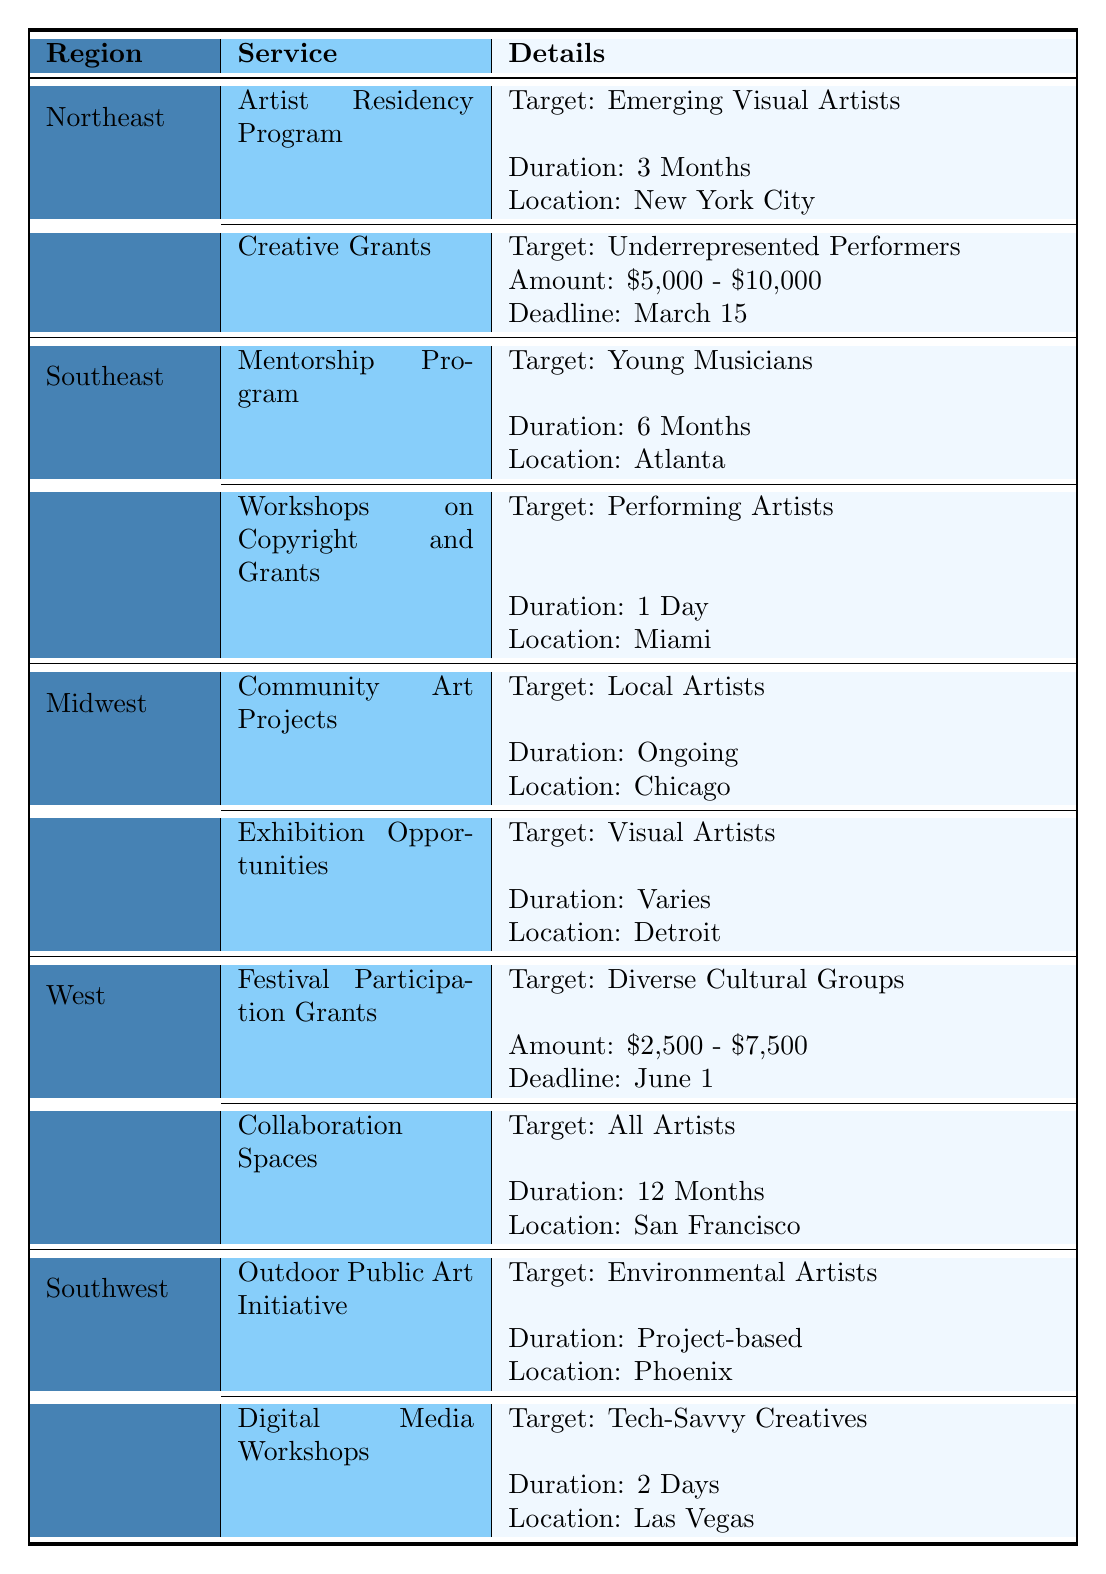What services are offered for emerging visual artists in the Northeast? The table shows that in the Northeast, the Artist Residency Program targets emerging visual artists.
Answer: Artist Residency Program What is the application deadline for the Creative Grants in the Northeast region? Looking at the Northeast section, the application deadline for Creative Grants is March 15.
Answer: March 15 How many months does the Mentorship Program last for young musicians in the Southeast? The table states that the Mentorship Program lasts for 6 months.
Answer: 6 Months Are there any services for performing artists in the Southeast region? Yes, the Southeast region offers Workshops on Copyright and Grants, which targets performing artists.
Answer: Yes What is the combined duration of services for local artists in the Midwest? For local artists in the Midwest, there is one service called Community Art Projects with an ongoing duration, and another called Exhibition Opportunities with a variable duration. Since one is ongoing and the other varies, we cannot assign a specific number to this question, indicating a need for deeper qualitative reasoning rather than a numeric answer.
Answer: Ongoing and varies Which region provides collaboration spaces for all artists? The table indicates that collaboration spaces are offered in the West region for all artists with a duration of 12 months.
Answer: West Which service has the widest target audience among the regions? In the West region, the Collaboration Spaces service targets "All Artists," which covers a broader audience compared to other specific target audiences mentioned in the table.
Answer: Collaboration Spaces In which city is the Festival Participation Grants located? The Festival Participation Grants are offered in the city of San Francisco, as noted in the West region section of the table.
Answer: San Francisco What is the range of amounts for Festival Participation Grants? According to the West region, the amount for Festival Participation Grants ranges from $2,500 to $7,500.
Answer: $2,500 - $7,500 